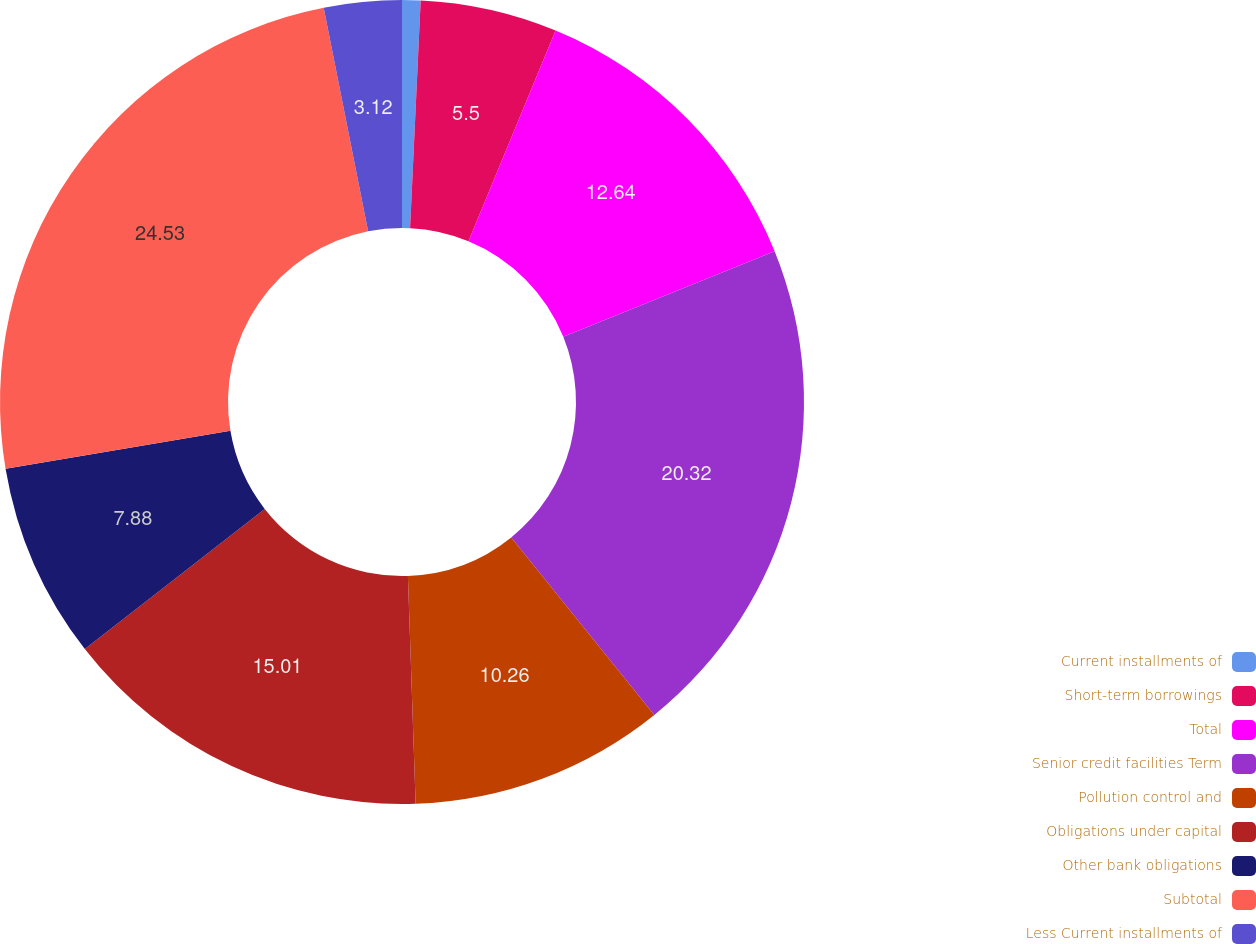Convert chart to OTSL. <chart><loc_0><loc_0><loc_500><loc_500><pie_chart><fcel>Current installments of<fcel>Short-term borrowings<fcel>Total<fcel>Senior credit facilities Term<fcel>Pollution control and<fcel>Obligations under capital<fcel>Other bank obligations<fcel>Subtotal<fcel>Less Current installments of<nl><fcel>0.74%<fcel>5.5%<fcel>12.64%<fcel>20.32%<fcel>10.26%<fcel>15.01%<fcel>7.88%<fcel>24.53%<fcel>3.12%<nl></chart> 